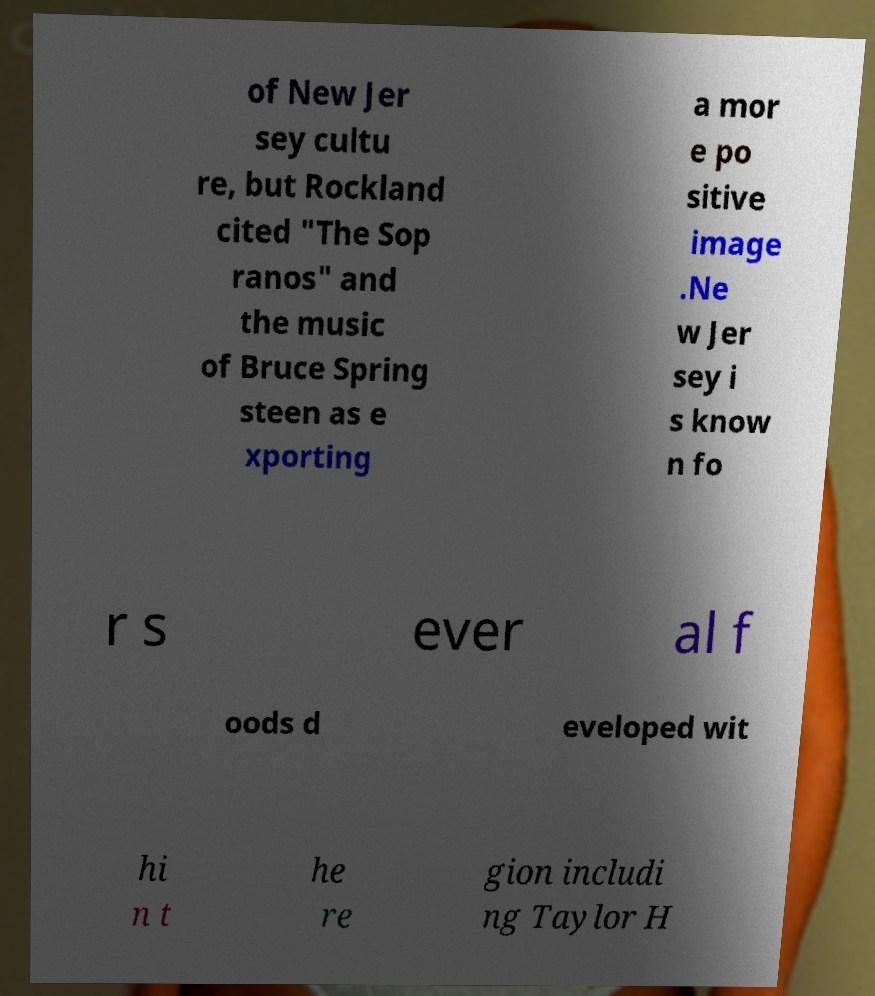Could you extract and type out the text from this image? of New Jer sey cultu re, but Rockland cited "The Sop ranos" and the music of Bruce Spring steen as e xporting a mor e po sitive image .Ne w Jer sey i s know n fo r s ever al f oods d eveloped wit hi n t he re gion includi ng Taylor H 